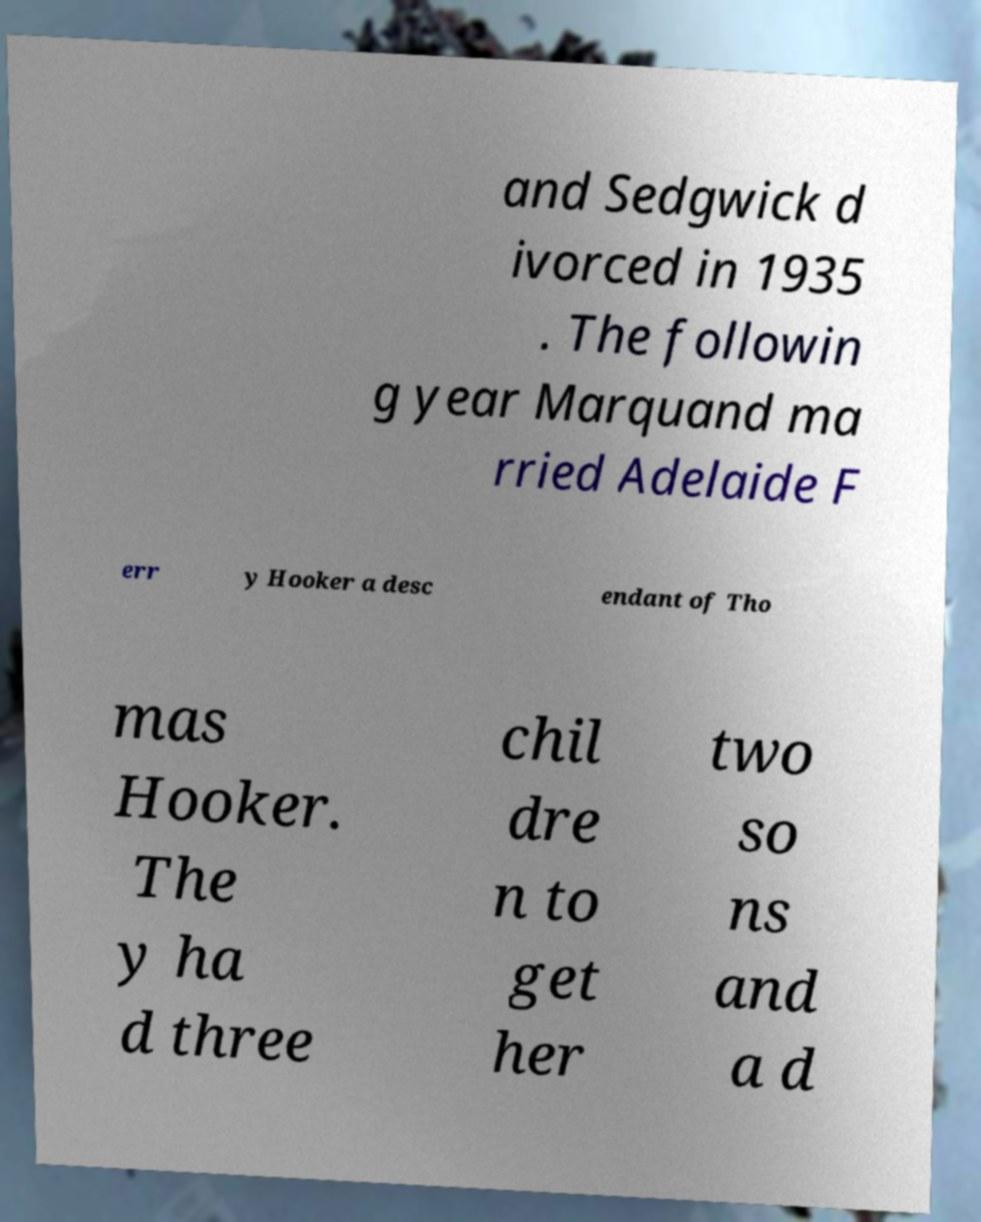Can you read and provide the text displayed in the image?This photo seems to have some interesting text. Can you extract and type it out for me? and Sedgwick d ivorced in 1935 . The followin g year Marquand ma rried Adelaide F err y Hooker a desc endant of Tho mas Hooker. The y ha d three chil dre n to get her two so ns and a d 